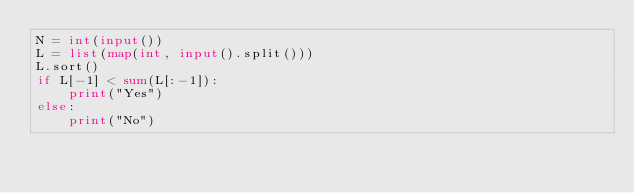<code> <loc_0><loc_0><loc_500><loc_500><_Python_>N = int(input())
L = list(map(int, input().split()))
L.sort()
if L[-1] < sum(L[:-1]):
    print("Yes")
else:
    print("No")
</code> 